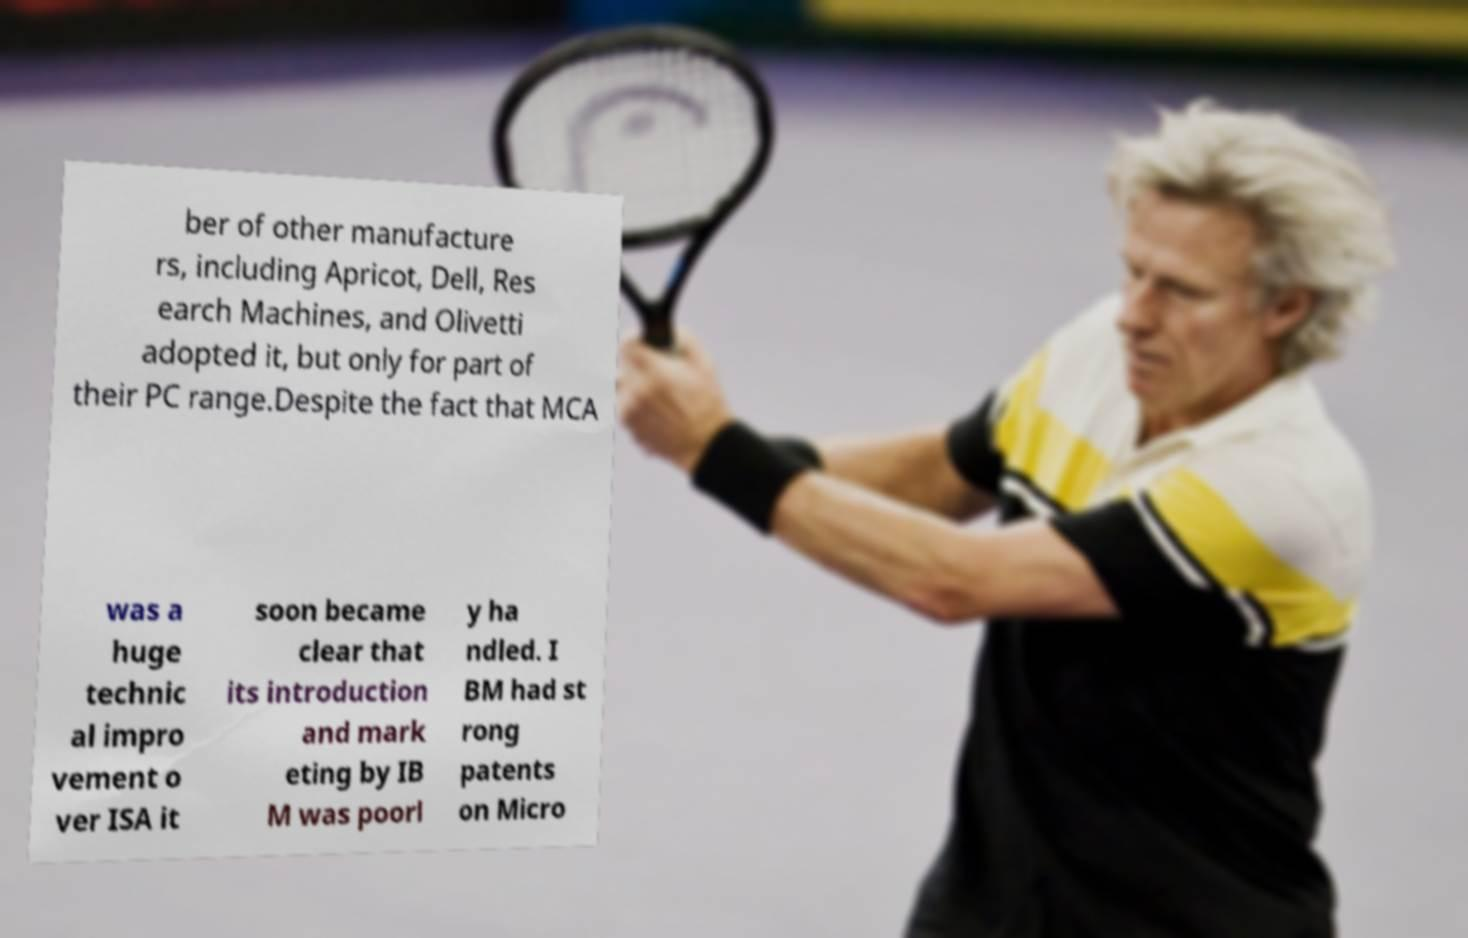Can you read and provide the text displayed in the image?This photo seems to have some interesting text. Can you extract and type it out for me? ber of other manufacture rs, including Apricot, Dell, Res earch Machines, and Olivetti adopted it, but only for part of their PC range.Despite the fact that MCA was a huge technic al impro vement o ver ISA it soon became clear that its introduction and mark eting by IB M was poorl y ha ndled. I BM had st rong patents on Micro 